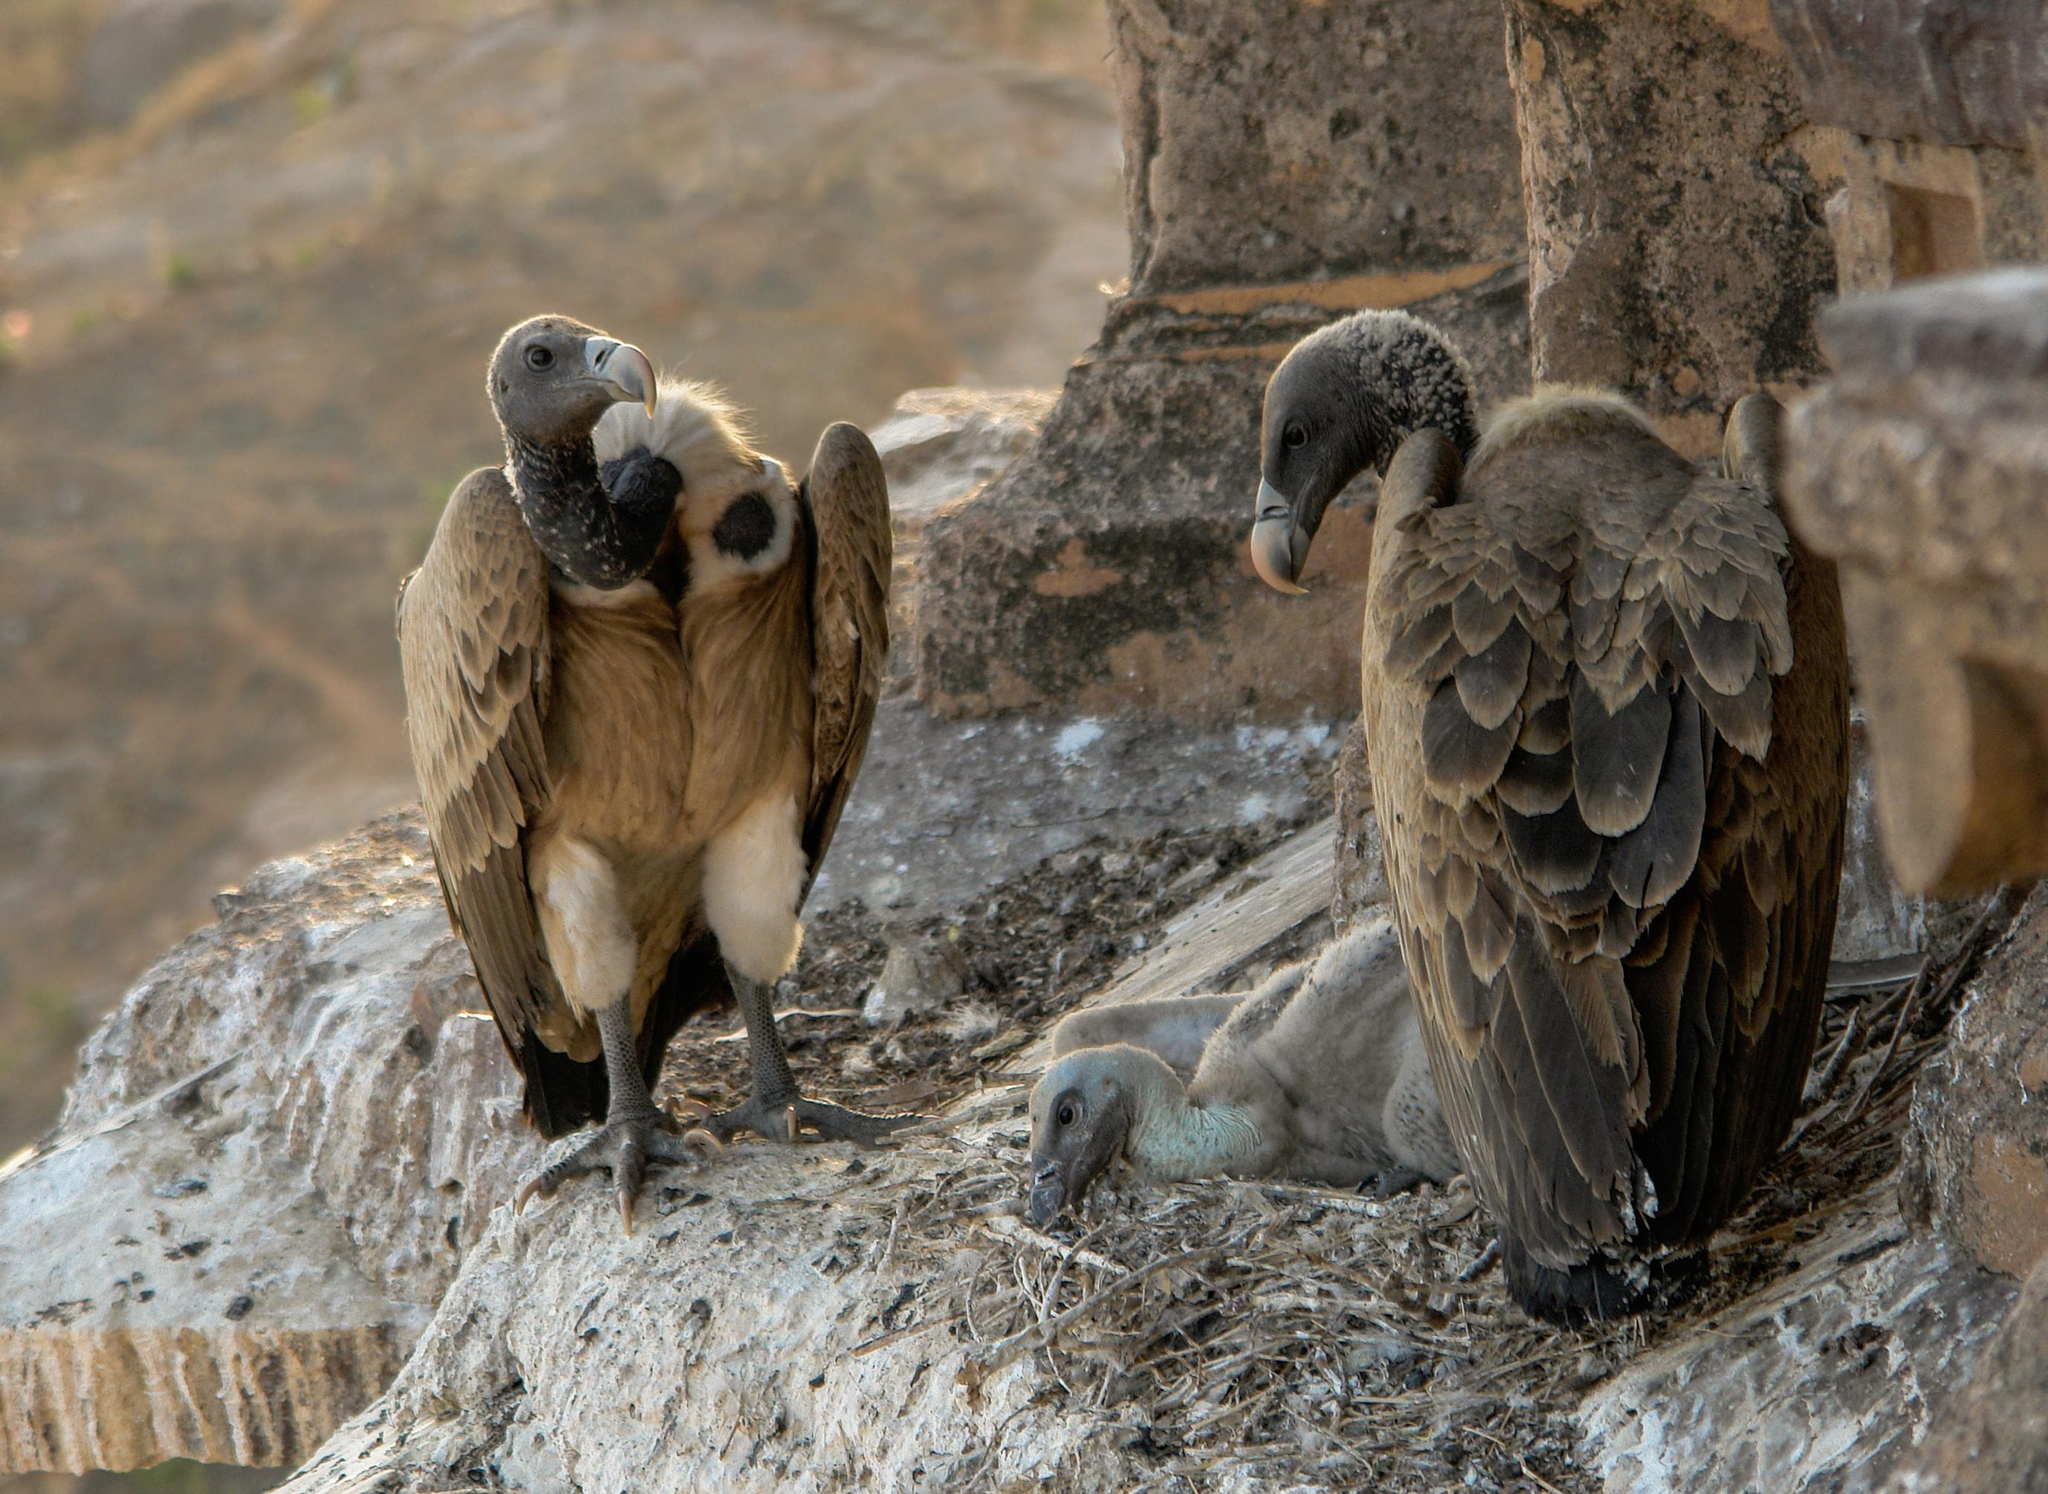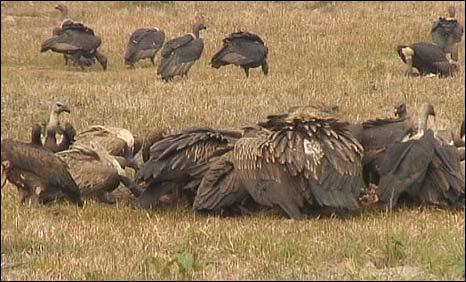The first image is the image on the left, the second image is the image on the right. For the images displayed, is the sentence "Some of the birds are eating something that is on the ground." factually correct? Answer yes or no. Yes. The first image is the image on the left, the second image is the image on the right. Examine the images to the left and right. Is the description "There is exactly one bird with its wings folded in the image on the right" accurate? Answer yes or no. No. 